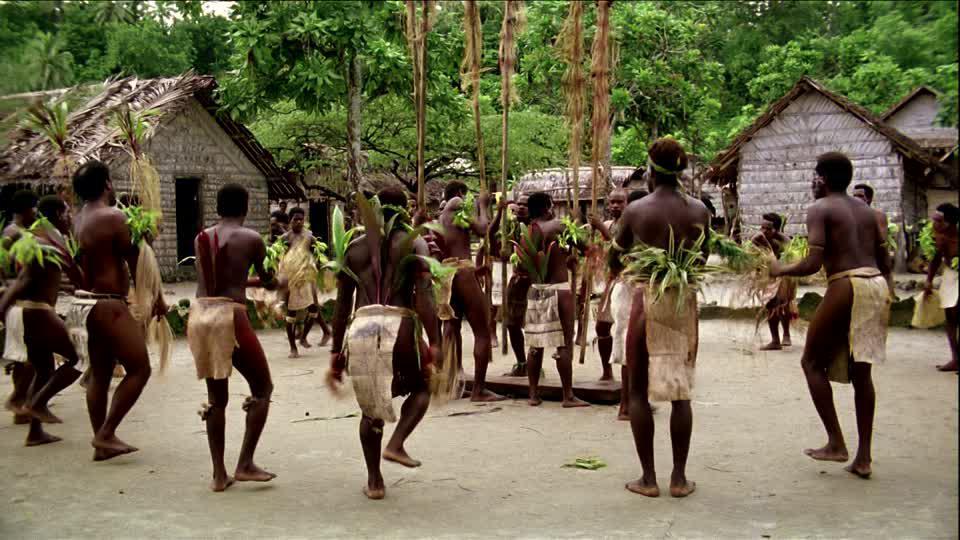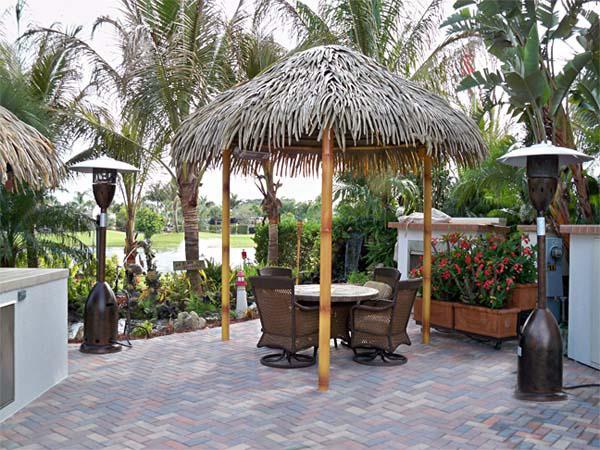The first image is the image on the left, the second image is the image on the right. For the images shown, is this caption "One image shows a thatched umbrella shape over a seating area with a round table." true? Answer yes or no. Yes. The first image is the image on the left, the second image is the image on the right. Evaluate the accuracy of this statement regarding the images: "In the left image a table is covered by a roof.". Is it true? Answer yes or no. No. 